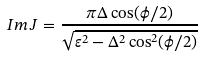<formula> <loc_0><loc_0><loc_500><loc_500>I m \, J = \frac { \pi \Delta \cos ( \phi / 2 ) } { \sqrt { \varepsilon ^ { 2 } - \Delta ^ { 2 } \cos ^ { 2 } ( \phi / 2 ) } }</formula> 